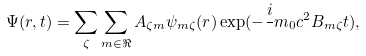Convert formula to latex. <formula><loc_0><loc_0><loc_500><loc_500>\Psi ( { r } , t ) = \sum _ { \zeta } \sum _ { m \in \Re } A _ { \zeta m } \psi _ { m \zeta } ( { r } ) \exp ( - \frac { i } { } m _ { 0 } c ^ { 2 } B _ { m \zeta } t ) ,</formula> 